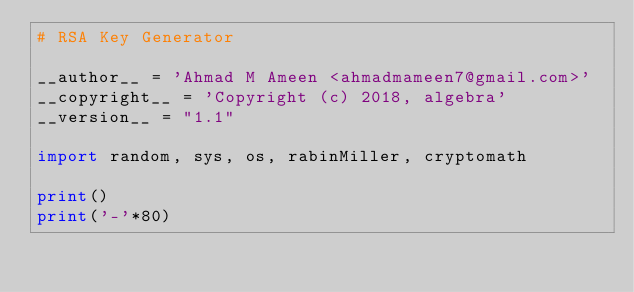Convert code to text. <code><loc_0><loc_0><loc_500><loc_500><_Python_># RSA Key Generator

__author__ = 'Ahmad M Ameen <ahmadmameen7@gmail.com>'
__copyright__ = 'Copyright (c) 2018, algebra'
__version__ = "1.1"

import random, sys, os, rabinMiller, cryptomath

print()
print('-'*80)</code> 